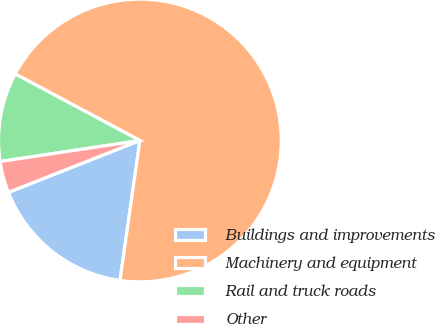Convert chart to OTSL. <chart><loc_0><loc_0><loc_500><loc_500><pie_chart><fcel>Buildings and improvements<fcel>Machinery and equipment<fcel>Rail and truck roads<fcel>Other<nl><fcel>16.77%<fcel>69.45%<fcel>10.18%<fcel>3.6%<nl></chart> 